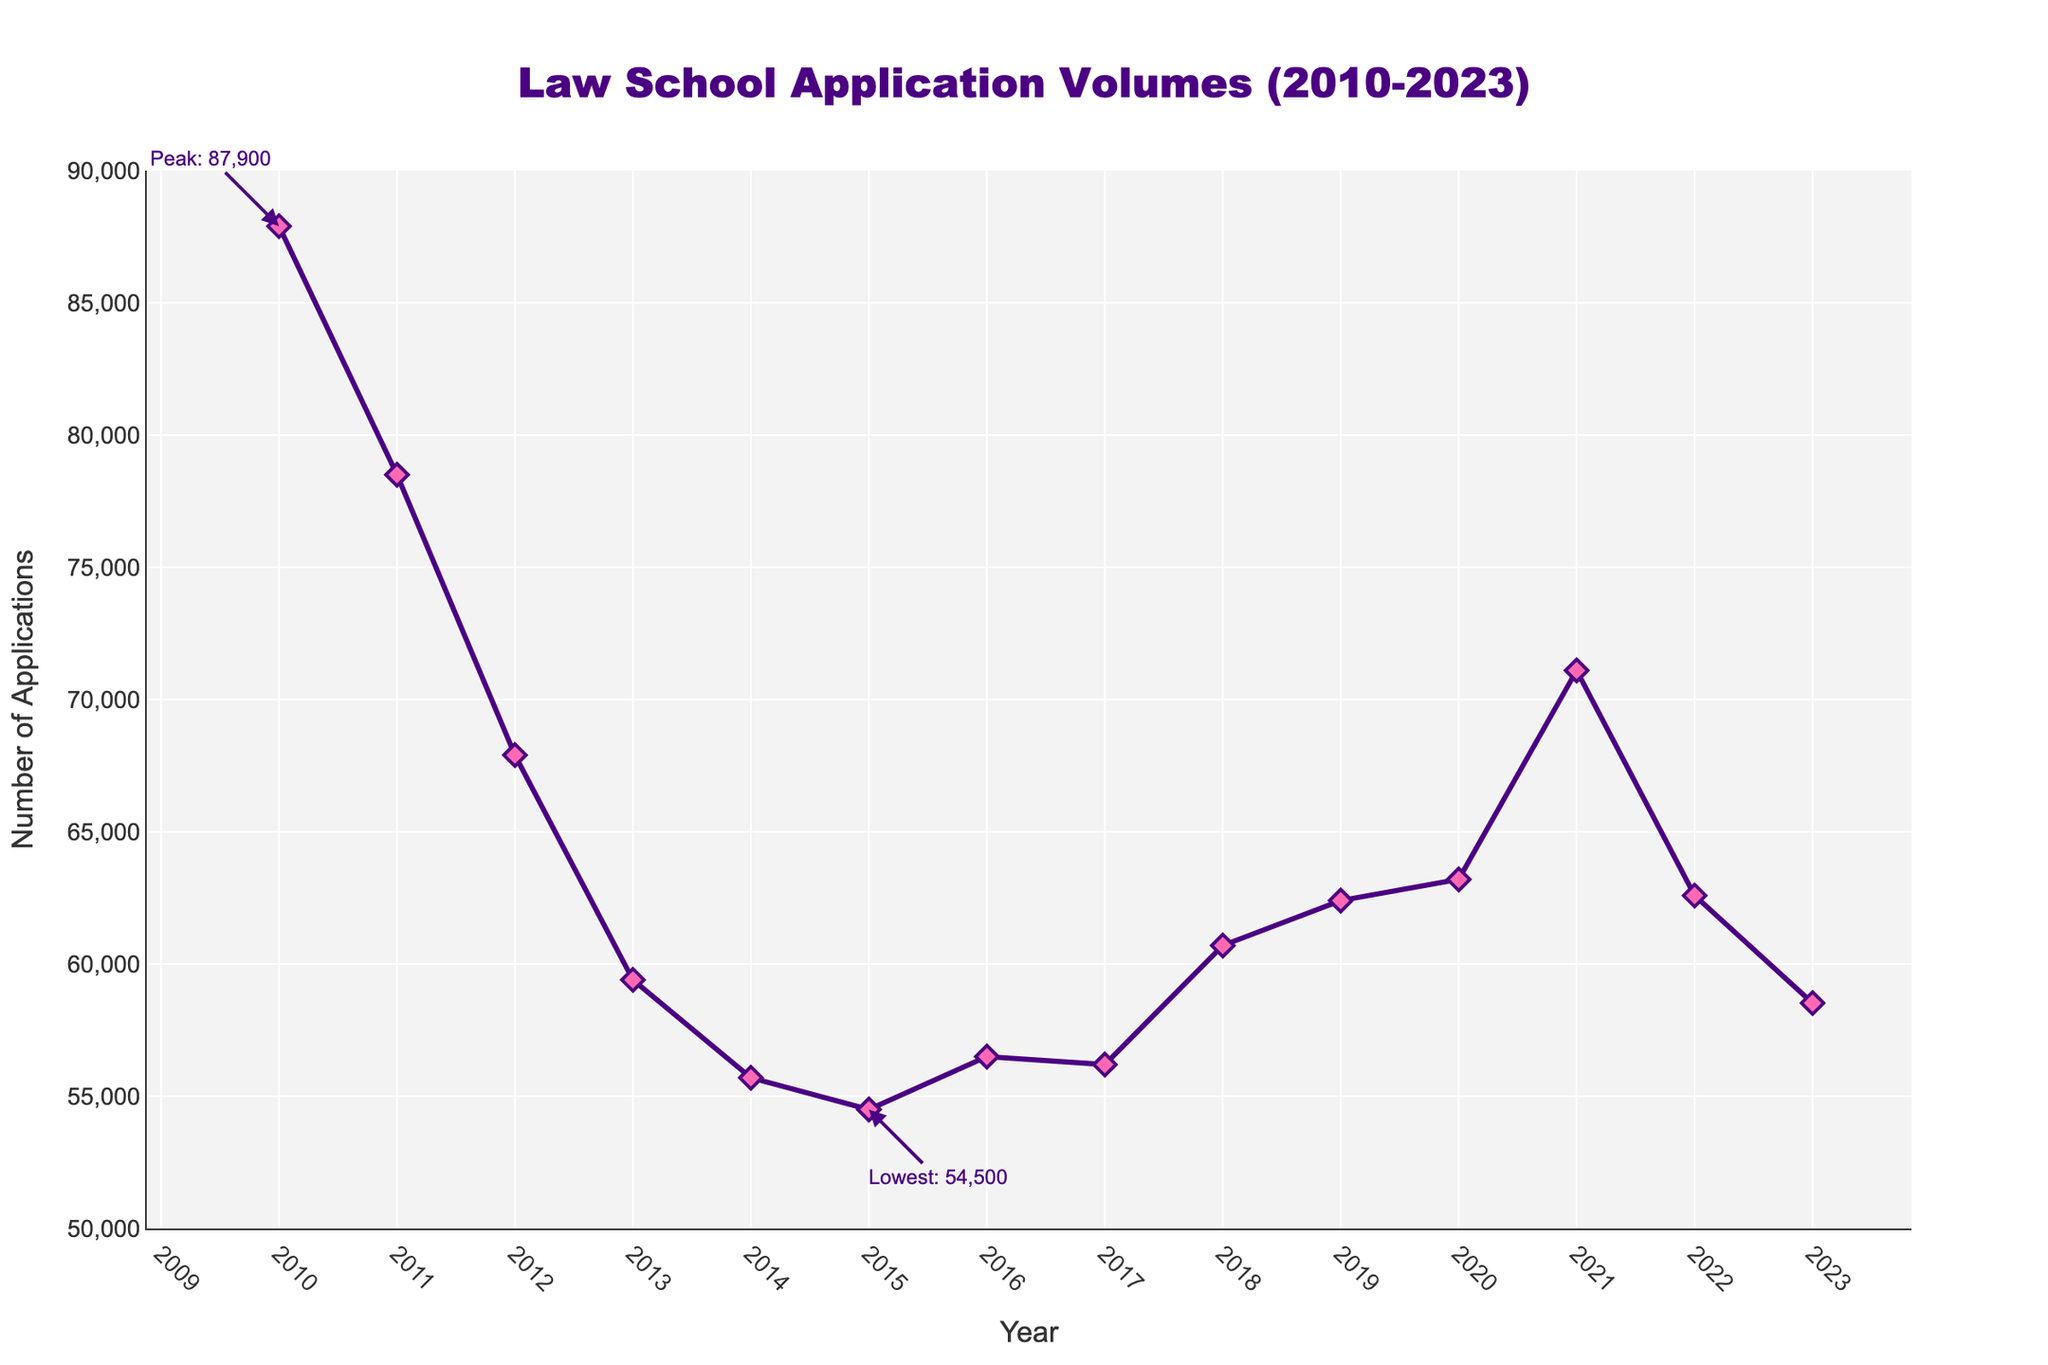What was the peak number of applications, and in which year did it occur? The highest point on the line chart corresponds to the year 2010 with an annotation indicating "Peak: 87,900".
Answer: 87,900 in 2010 What was the lowest number of applications, and in which year did it occur? The lowest point on the line chart corresponds to the year 2015 with an annotation indicating "Lowest: 54,500".
Answer: 54,500 in 2015 By how much did the number of applications decrease from 2010 to 2015? The number of applications in 2010 was 87,900 and in 2015 it was 54,500. The difference is 87,900 - 54,500.
Answer: 33,400 What was the general trend in law school applications from 2010 to 2015? From 2010 to 2015, the line chart shows a downward trend. The number of applications decreased consistently over these years.
Answer: Decreasing How did the number of applications change from 2015 to 2020? In 2015, the number of applications was 54,500 and in 2020 it increased to 63,200, indicating an upward trend over these years.
Answer: Increased Compare the number of applications in 2013 and 2023. Which year had more applications and by how much? In 2013, there were 59,400 applications and in 2023 there were 58,524 applications. The difference is 59,400 - 58,524.
Answer: 2013 by 876 What is the average number of applications per year from 2010 to 2023? Sum the total number of applications from 2010 to 2023 and divide by the number of years (14). Total = 87900 + 78500 + 67900 + 59400 + 55700 + 54500 + 56500 + 56200 + 60700 + 62400 + 63200 + 71100 + 62589 + 58524 = 897213. Average = 897213 / 14.
Answer: 64,087.36 During which period did the number of applications increase after previously declining? The number of applications declined until 2015 and then began to increase again up to 2021.
Answer: 2015 to 2021 What is the approximate range within which the majority of the application values fall in the line chart? The majority of the values fall between the lowest point of 54,500 and the highest point (excluding the peak) around 71,100.
Answer: 54,500 to 71,100 Is there any year where the application numbers are nearly the same? If so, which years? The years 2016 (56,500) and 2017 (56,200) have nearly the same number of applications, with a difference of only 300 applications.
Answer: 2016 and 2017 